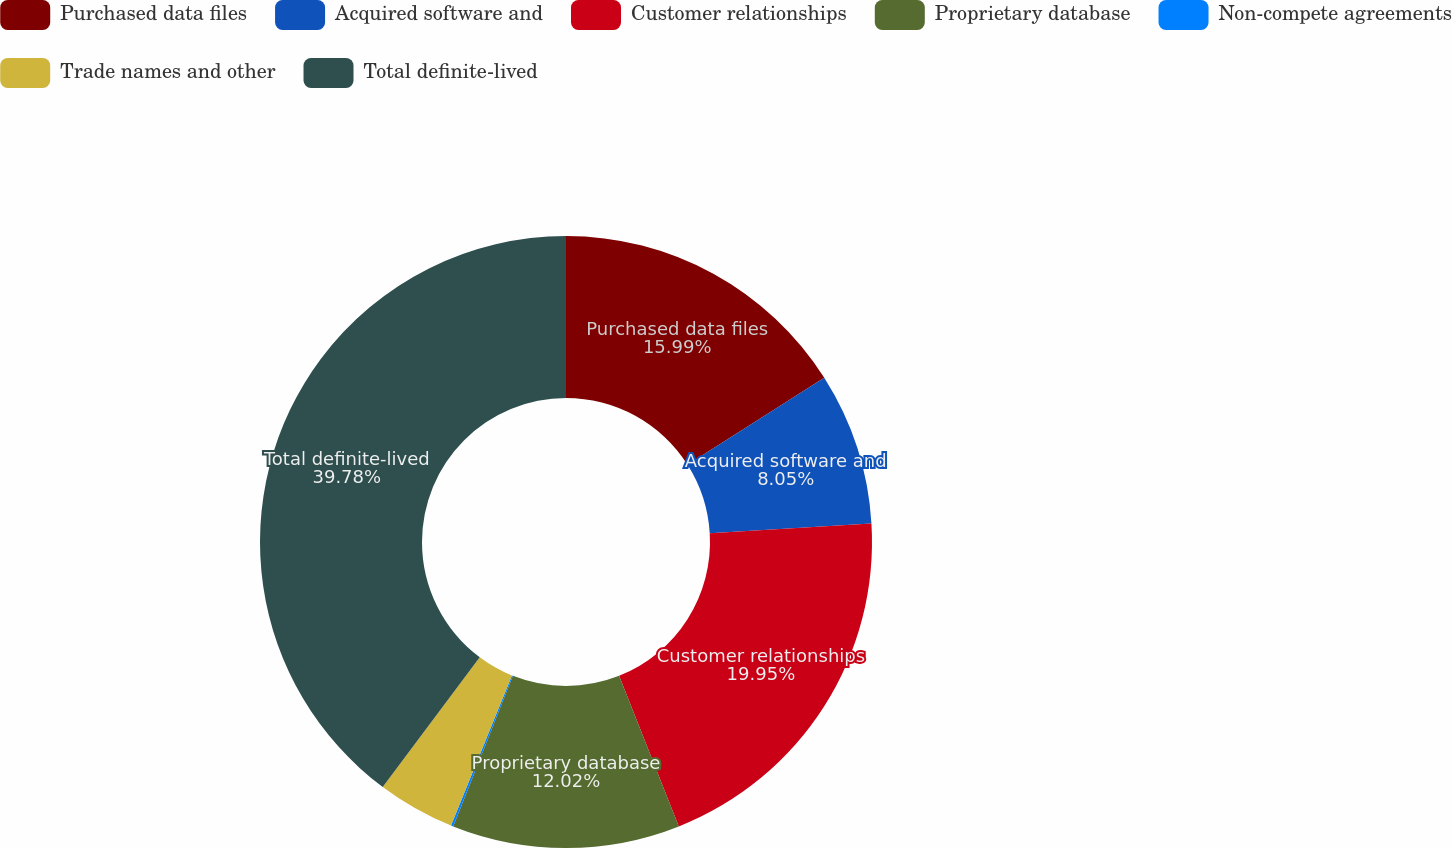<chart> <loc_0><loc_0><loc_500><loc_500><pie_chart><fcel>Purchased data files<fcel>Acquired software and<fcel>Customer relationships<fcel>Proprietary database<fcel>Non-compete agreements<fcel>Trade names and other<fcel>Total definite-lived<nl><fcel>15.99%<fcel>8.05%<fcel>19.95%<fcel>12.02%<fcel>0.12%<fcel>4.09%<fcel>39.78%<nl></chart> 